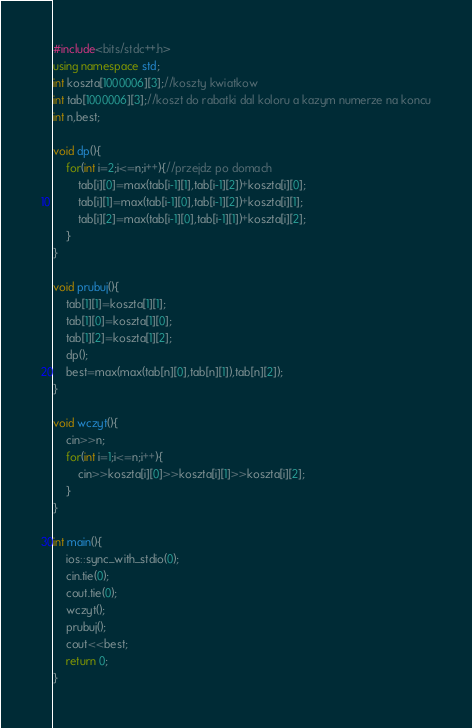Convert code to text. <code><loc_0><loc_0><loc_500><loc_500><_C++_>#include<bits/stdc++.h>
using namespace std;
int koszta[1000006][3];//koszty kwiatkow
int tab[1000006][3];//koszt do rabatki dal koloru a kazym numerze na koncu
int n,best;

void dp(){
	for(int i=2;i<=n;i++){//przejdz po domach
		tab[i][0]=max(tab[i-1][1],tab[i-1][2])+koszta[i][0];
		tab[i][1]=max(tab[i-1][0],tab[i-1][2])+koszta[i][1];
		tab[i][2]=max(tab[i-1][0],tab[i-1][1])+koszta[i][2];
	}
}

void prubuj(){
	tab[1][1]=koszta[1][1];
	tab[1][0]=koszta[1][0];
	tab[1][2]=koszta[1][2];
	dp();
	best=max(max(tab[n][0],tab[n][1]),tab[n][2]);
}

void wczyt(){
	cin>>n;
	for(int i=1;i<=n;i++){
		cin>>koszta[i][0]>>koszta[i][1]>>koszta[i][2];
	}
}

int main(){
	ios::sync_with_stdio(0);
	cin.tie(0);
	cout.tie(0);
	wczyt();
	prubuj();
	cout<<best;
	return 0;
}</code> 